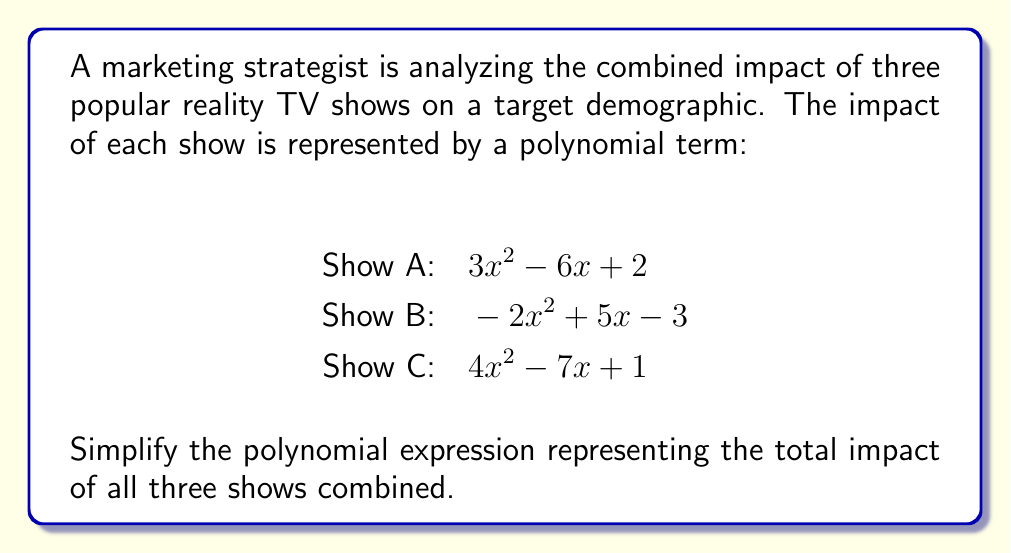Show me your answer to this math problem. To simplify the polynomial expression representing the combined impact of the three reality TV shows, we need to add the three polynomial terms together and then simplify by combining like terms.

Let's start by writing out the full expression:

$$(3x^2 - 6x + 2) + (-2x^2 + 5x - 3) + (4x^2 - 7x + 1)$$

Now, let's group like terms:

1. $x^2$ terms:
   $3x^2 + (-2x^2) + 4x^2 = 5x^2$

2. $x$ terms:
   $-6x + 5x + (-7x) = -8x$

3. Constant terms:
   $2 + (-3) + 1 = 0$

Now, we can write our simplified polynomial:

$$5x^2 - 8x + 0$$

Since adding zero doesn't change the value of an expression, we can omit the constant term.

Therefore, the final simplified polynomial is:

$$5x^2 - 8x$$

This polynomial represents the combined impact of all three reality TV shows on the target demographic.
Answer: $5x^2 - 8x$ 